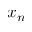<formula> <loc_0><loc_0><loc_500><loc_500>x _ { n }</formula> 